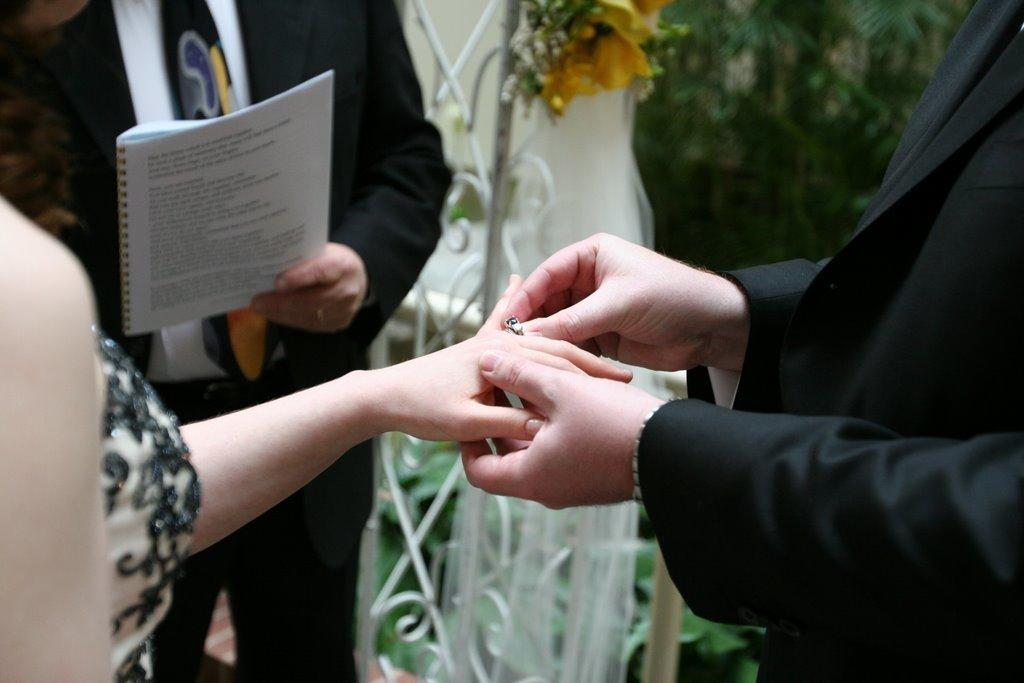How many people are present in the image? There are two people, a man and a woman, present in the image. What is the man holding in the image? The man is holding a ring. Where is the ring placed in the image? The ring is on the woman's finger. What can be seen in the background of the image? There is greenery and a person holding a book in the background of the image. What type of instrument is the man playing in the image? There is no instrument present in the image; the man is holding a ring. Is there an army visible in the image? No, there is no army present in the image. 